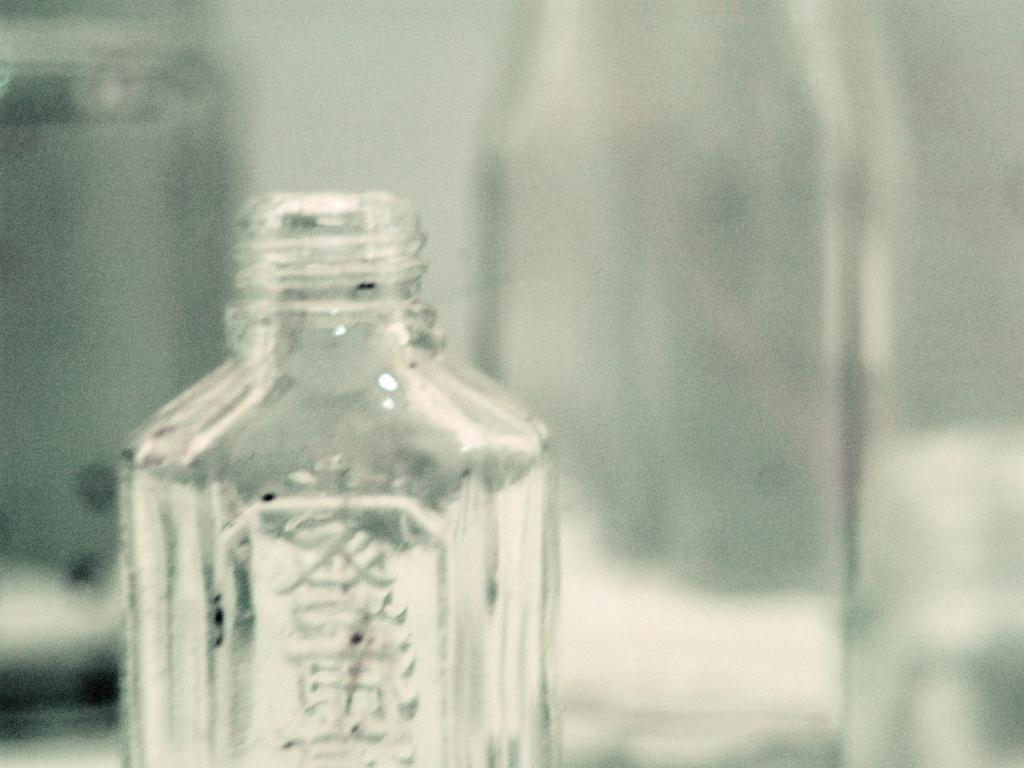What type of containers are visible in the image? There are glass bottles and a glass jar visible in the image. Can you describe the location of the central bottle? There is a bottle in the center of the image. What is located on the left side of the image? There is a glass jar on the left side of the image. Are there any other glass bottles visible in the image? Yes, there is another glass bottle in the background of the image. What type of plastic toy can be seen in the image? There is no plastic toy present in the image; it only features glass bottles and a glass jar. 